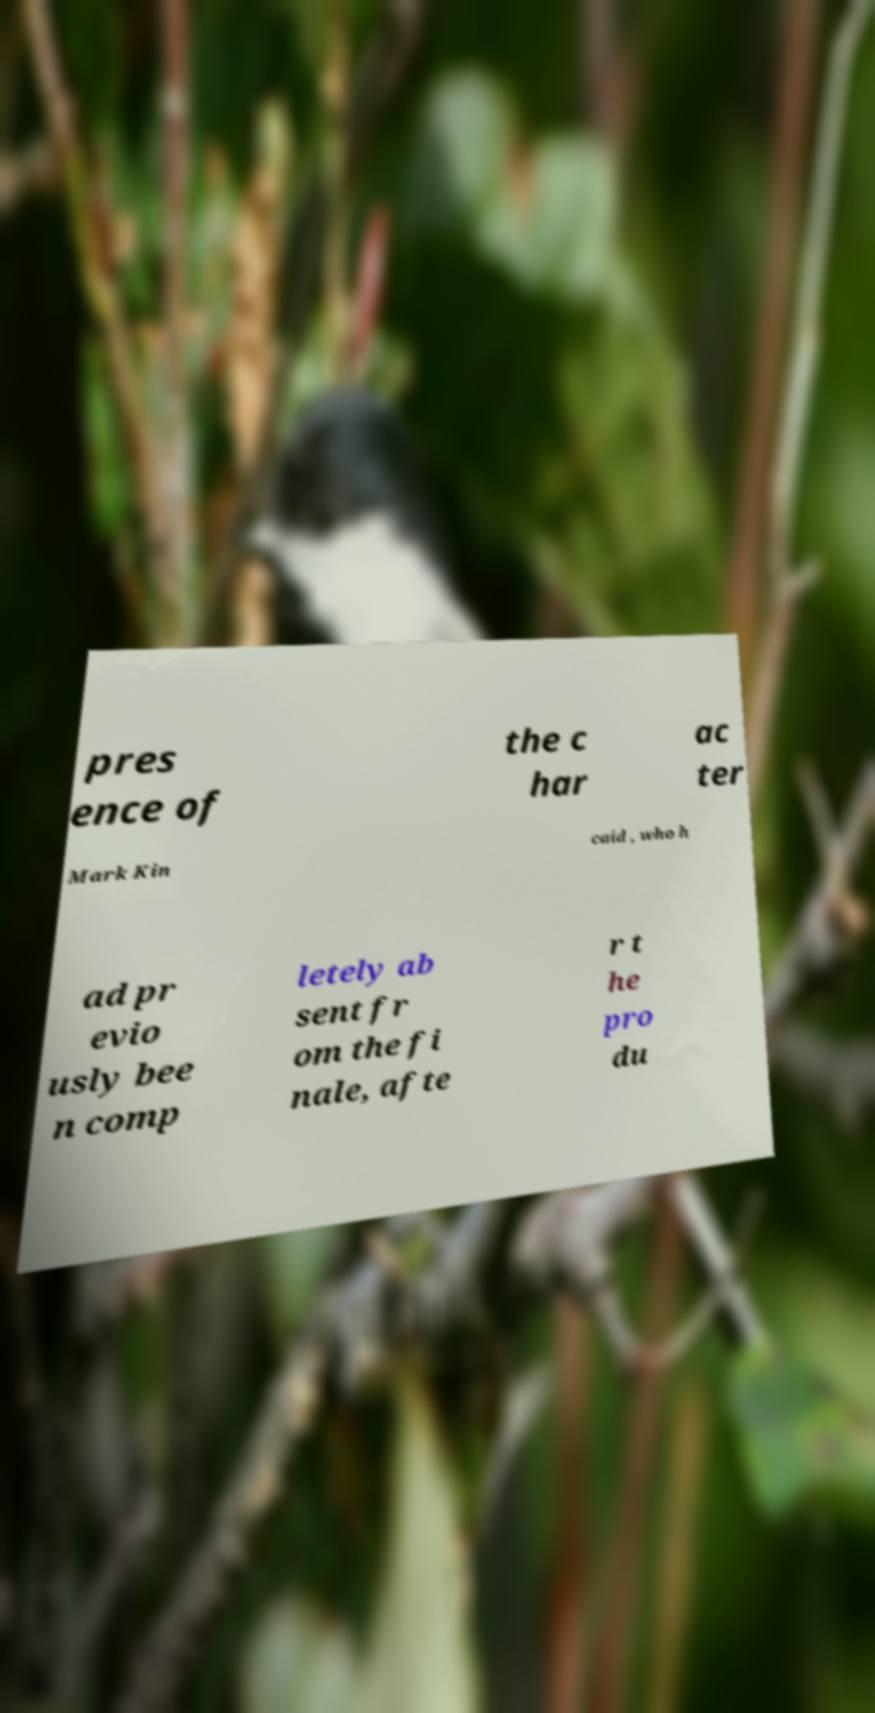Please read and relay the text visible in this image. What does it say? pres ence of the c har ac ter Mark Kin caid , who h ad pr evio usly bee n comp letely ab sent fr om the fi nale, afte r t he pro du 